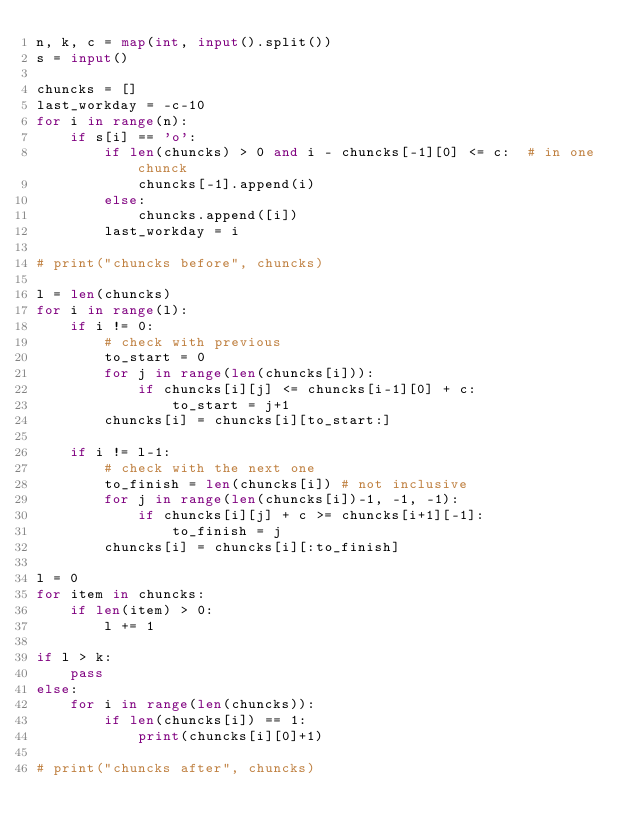<code> <loc_0><loc_0><loc_500><loc_500><_Python_>n, k, c = map(int, input().split())
s = input()

chuncks = []
last_workday = -c-10
for i in range(n):
	if s[i] == 'o':
		if len(chuncks) > 0 and i - chuncks[-1][0] <= c:  # in one chunck 
			chuncks[-1].append(i)
		else:
			chuncks.append([i])
		last_workday = i

# print("chuncks before", chuncks)

l = len(chuncks)
for i in range(l):
	if i != 0:
		# check with previous
		to_start = 0
		for j in range(len(chuncks[i])):
			if chuncks[i][j] <= chuncks[i-1][0] + c:
				to_start = j+1
		chuncks[i] = chuncks[i][to_start:]

	if i != l-1:
		# check with the next one
		to_finish = len(chuncks[i]) # not inclusive
		for j in range(len(chuncks[i])-1, -1, -1):
			if chuncks[i][j] + c >= chuncks[i+1][-1]:
				to_finish = j
		chuncks[i] = chuncks[i][:to_finish]

l = 0
for item in chuncks:
	if len(item) > 0:
		l += 1 

if l > k:
	pass
else:
	for i in range(len(chuncks)):
		if len(chuncks[i]) == 1:
			print(chuncks[i][0]+1)

# print("chuncks after", chuncks)
</code> 